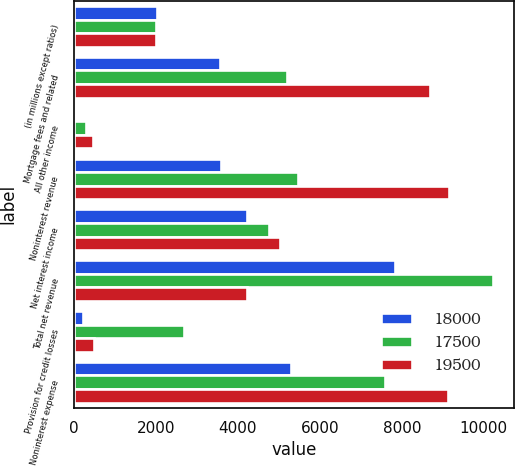<chart> <loc_0><loc_0><loc_500><loc_500><stacked_bar_chart><ecel><fcel>(in millions except ratios)<fcel>Mortgage fees and related<fcel>All other income<fcel>Noninterest revenue<fcel>Net interest income<fcel>Total net revenue<fcel>Provision for credit losses<fcel>Noninterest expense<nl><fcel>18000<fcel>2014<fcel>3560<fcel>37<fcel>3597<fcel>4229<fcel>7826<fcel>217<fcel>5284<nl><fcel>17500<fcel>2013<fcel>5195<fcel>283<fcel>5478<fcel>4758<fcel>10236<fcel>2681<fcel>7602<nl><fcel>19500<fcel>2012<fcel>8680<fcel>475<fcel>9155<fcel>5016<fcel>4229<fcel>490<fcel>9121<nl></chart> 